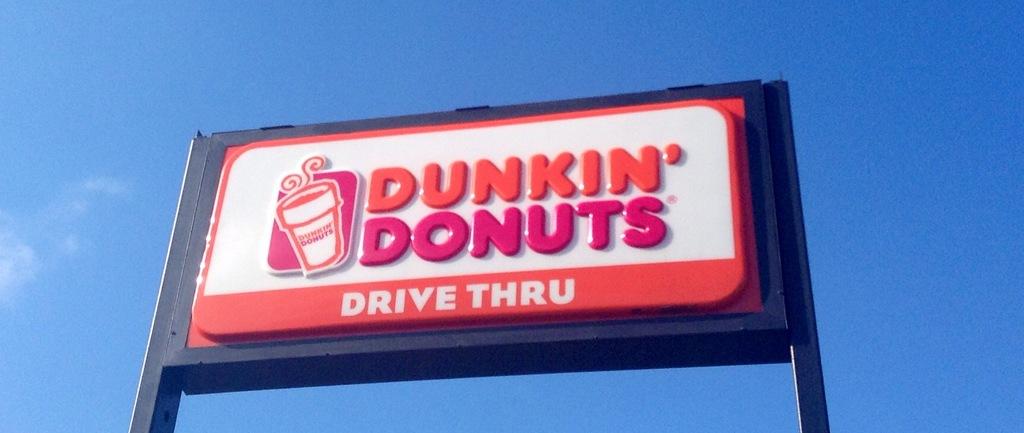How can you visit dunkin donuts?
Offer a very short reply. Drive thru. 